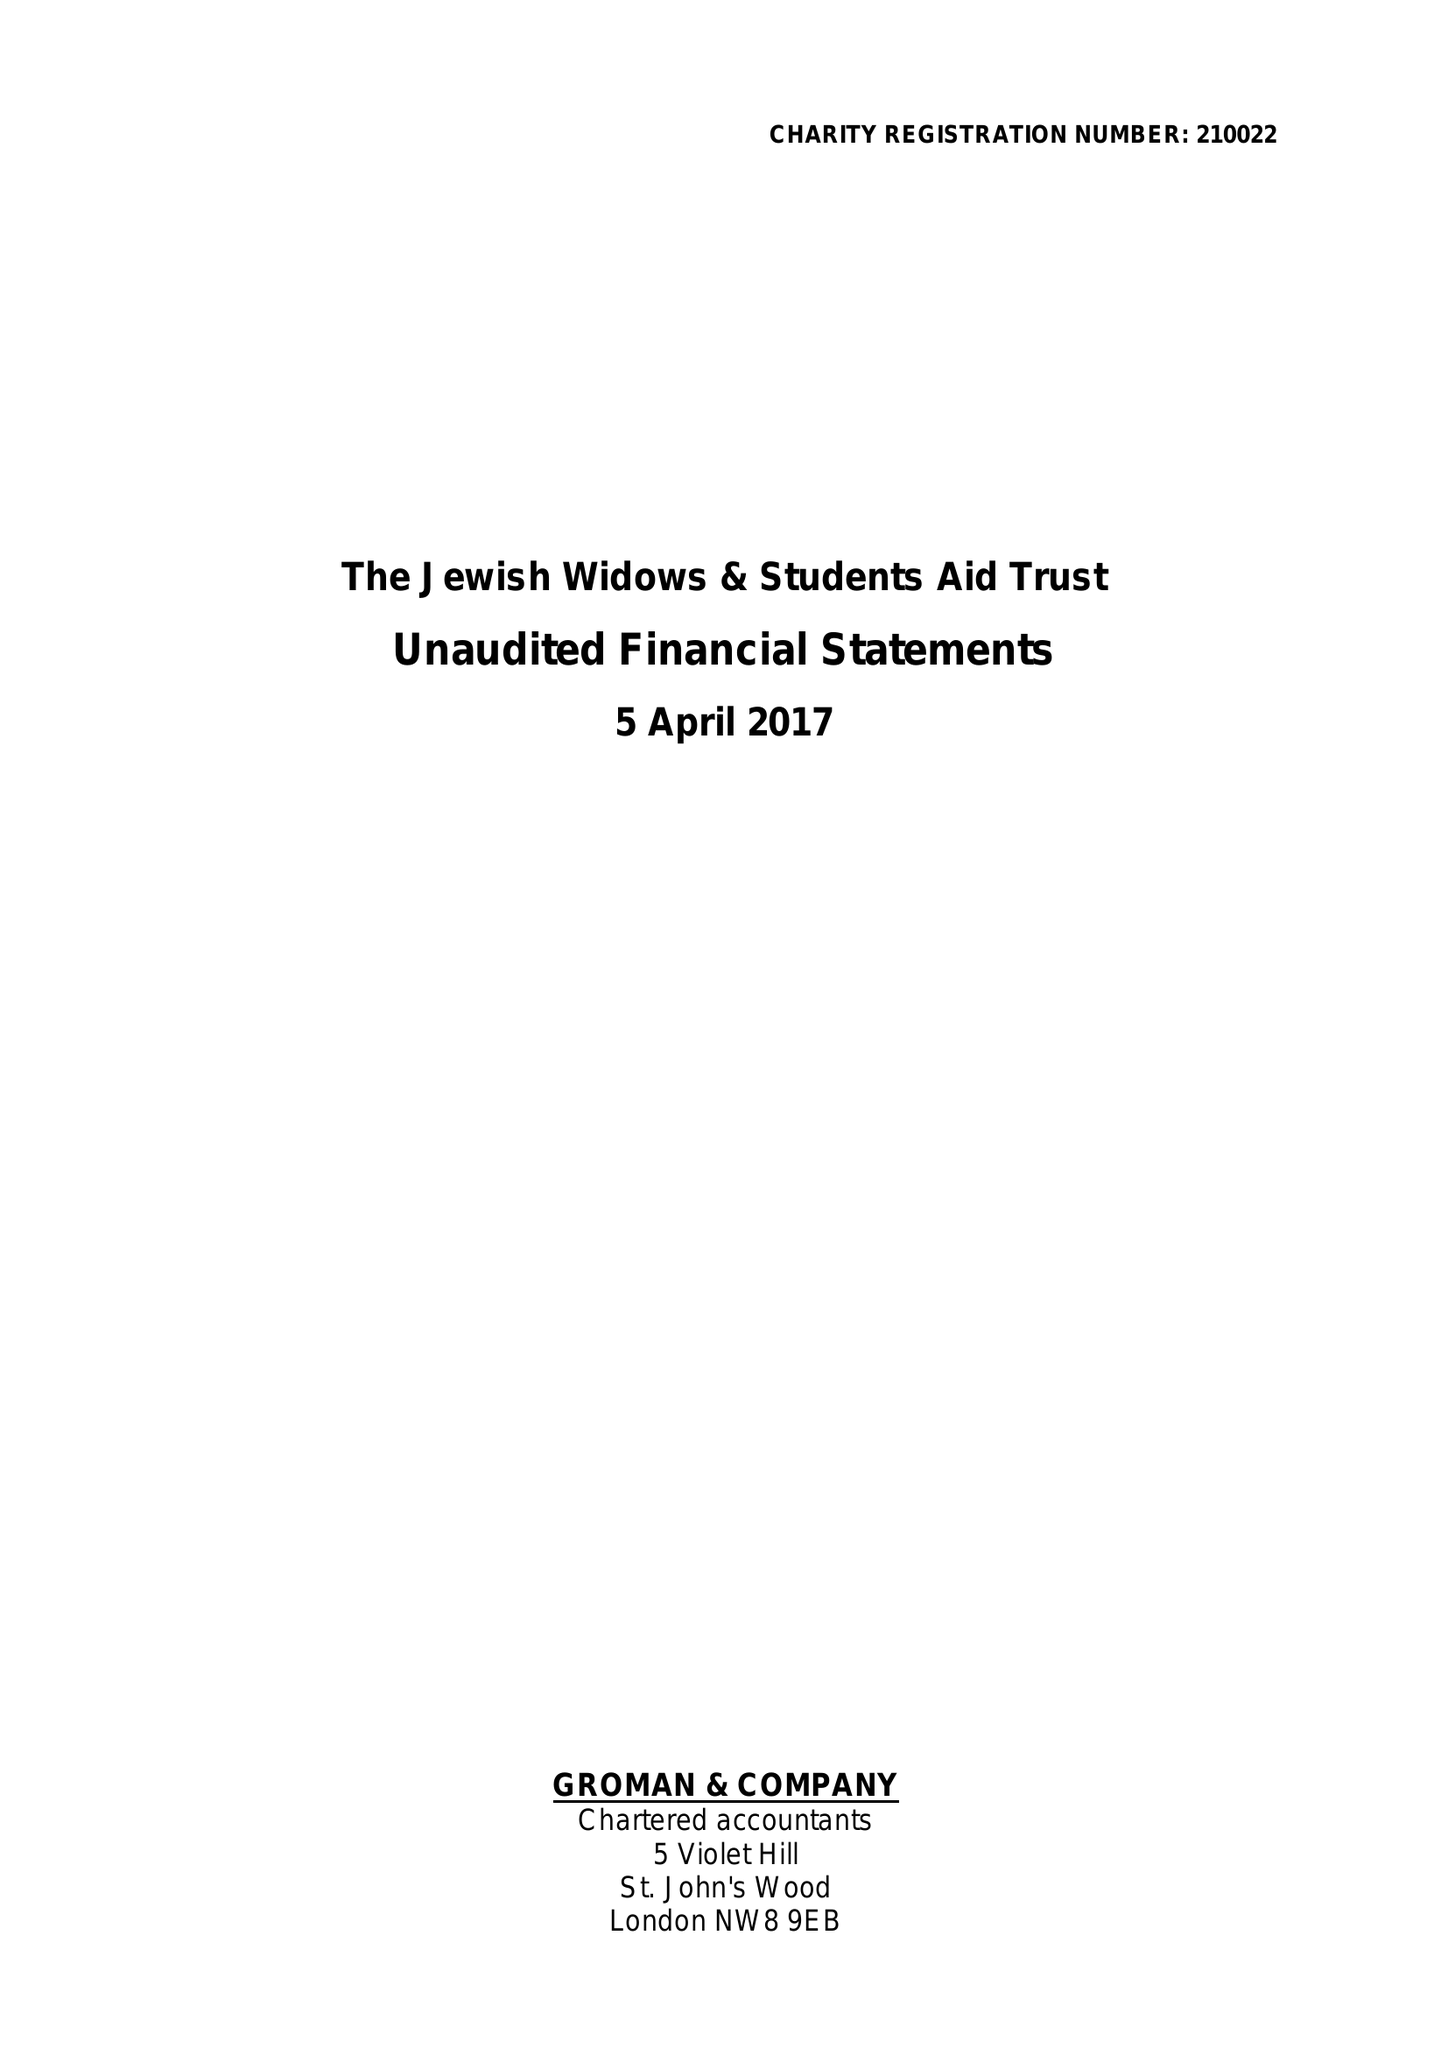What is the value for the address__postcode?
Answer the question using a single word or phrase. NW11 6UG 